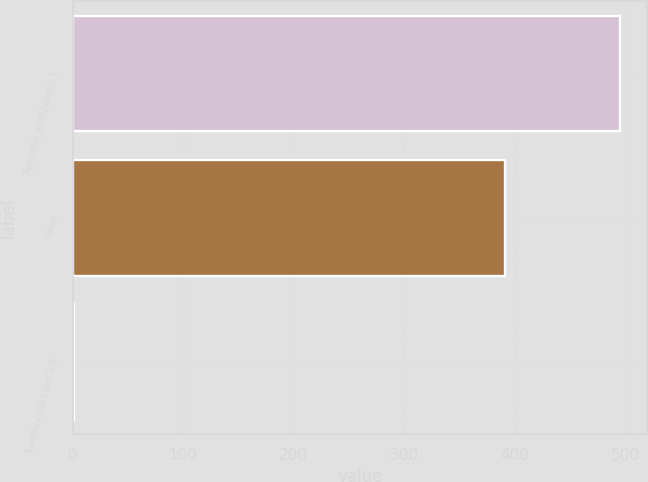<chart> <loc_0><loc_0><loc_500><loc_500><bar_chart><fcel>Fair value as of January 1<fcel>Sales<fcel>Transfers into Level 3 4<nl><fcel>495<fcel>391<fcel>1<nl></chart> 